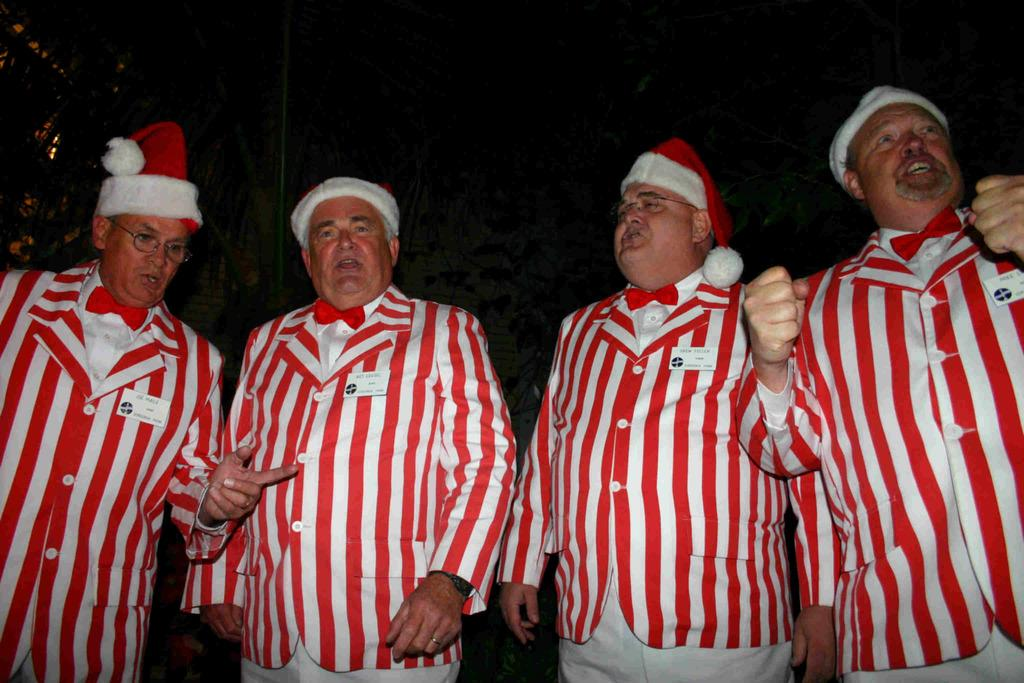How many people are in the image? There are four men standing in the image. What are the men wearing on their heads? The men are wearing wire caps. What can be observed about the background of the image? The background of the image is dark. What type of orange is being sliced by the moon in the image? There is no moon or orange present in the image; it features four men wearing wire caps with a dark background. 